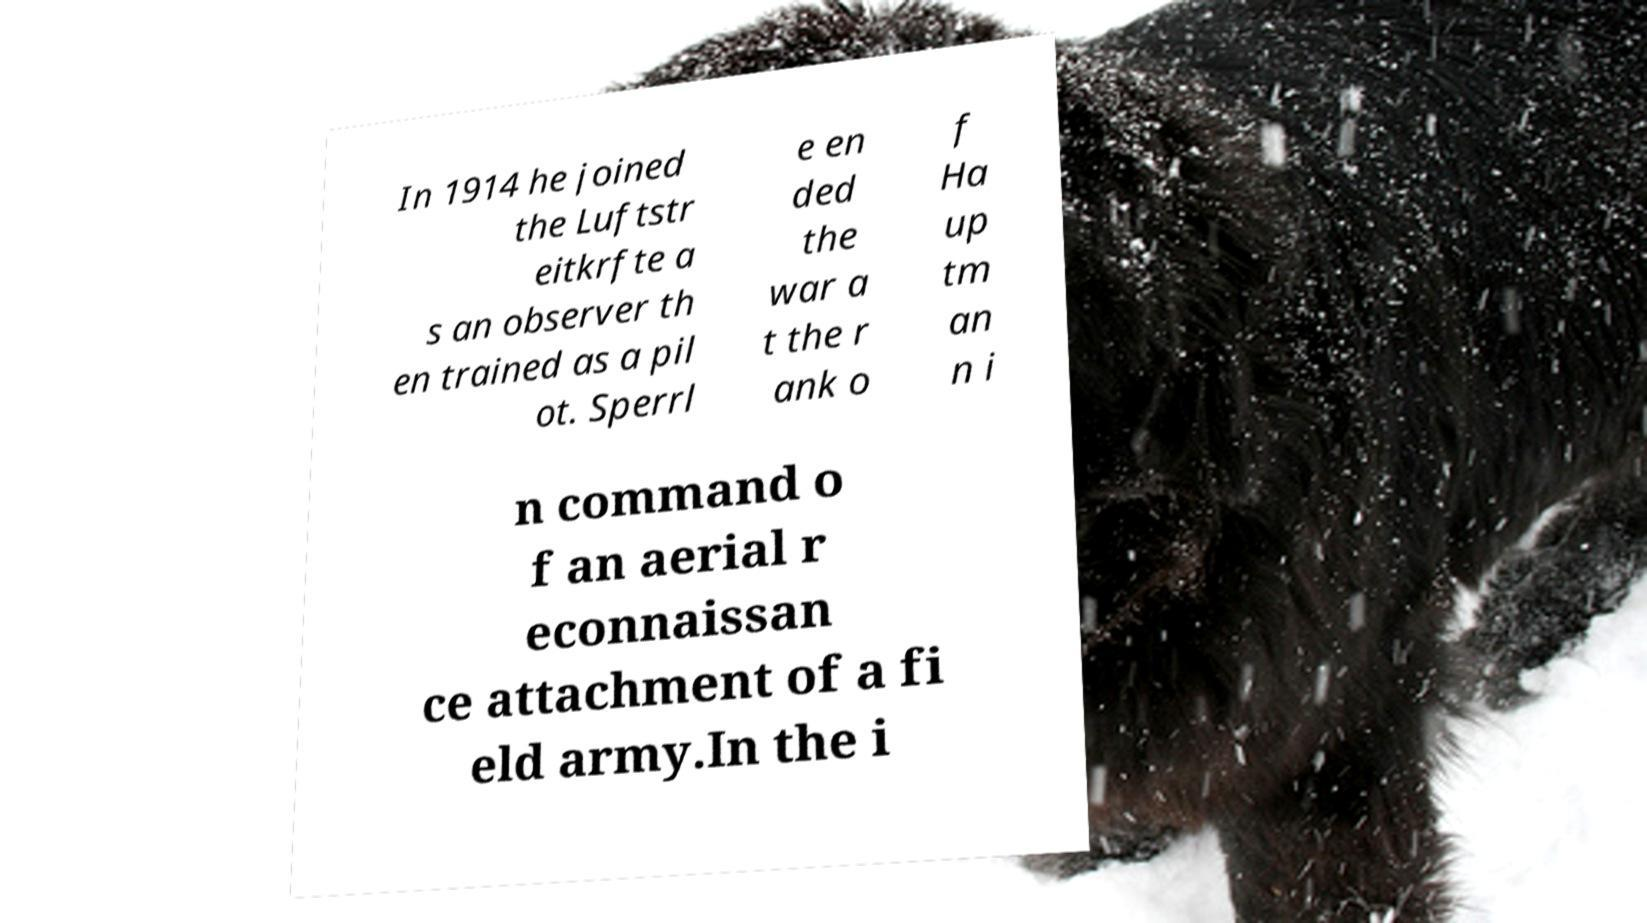Can you read and provide the text displayed in the image?This photo seems to have some interesting text. Can you extract and type it out for me? In 1914 he joined the Luftstr eitkrfte a s an observer th en trained as a pil ot. Sperrl e en ded the war a t the r ank o f Ha up tm an n i n command o f an aerial r econnaissan ce attachment of a fi eld army.In the i 